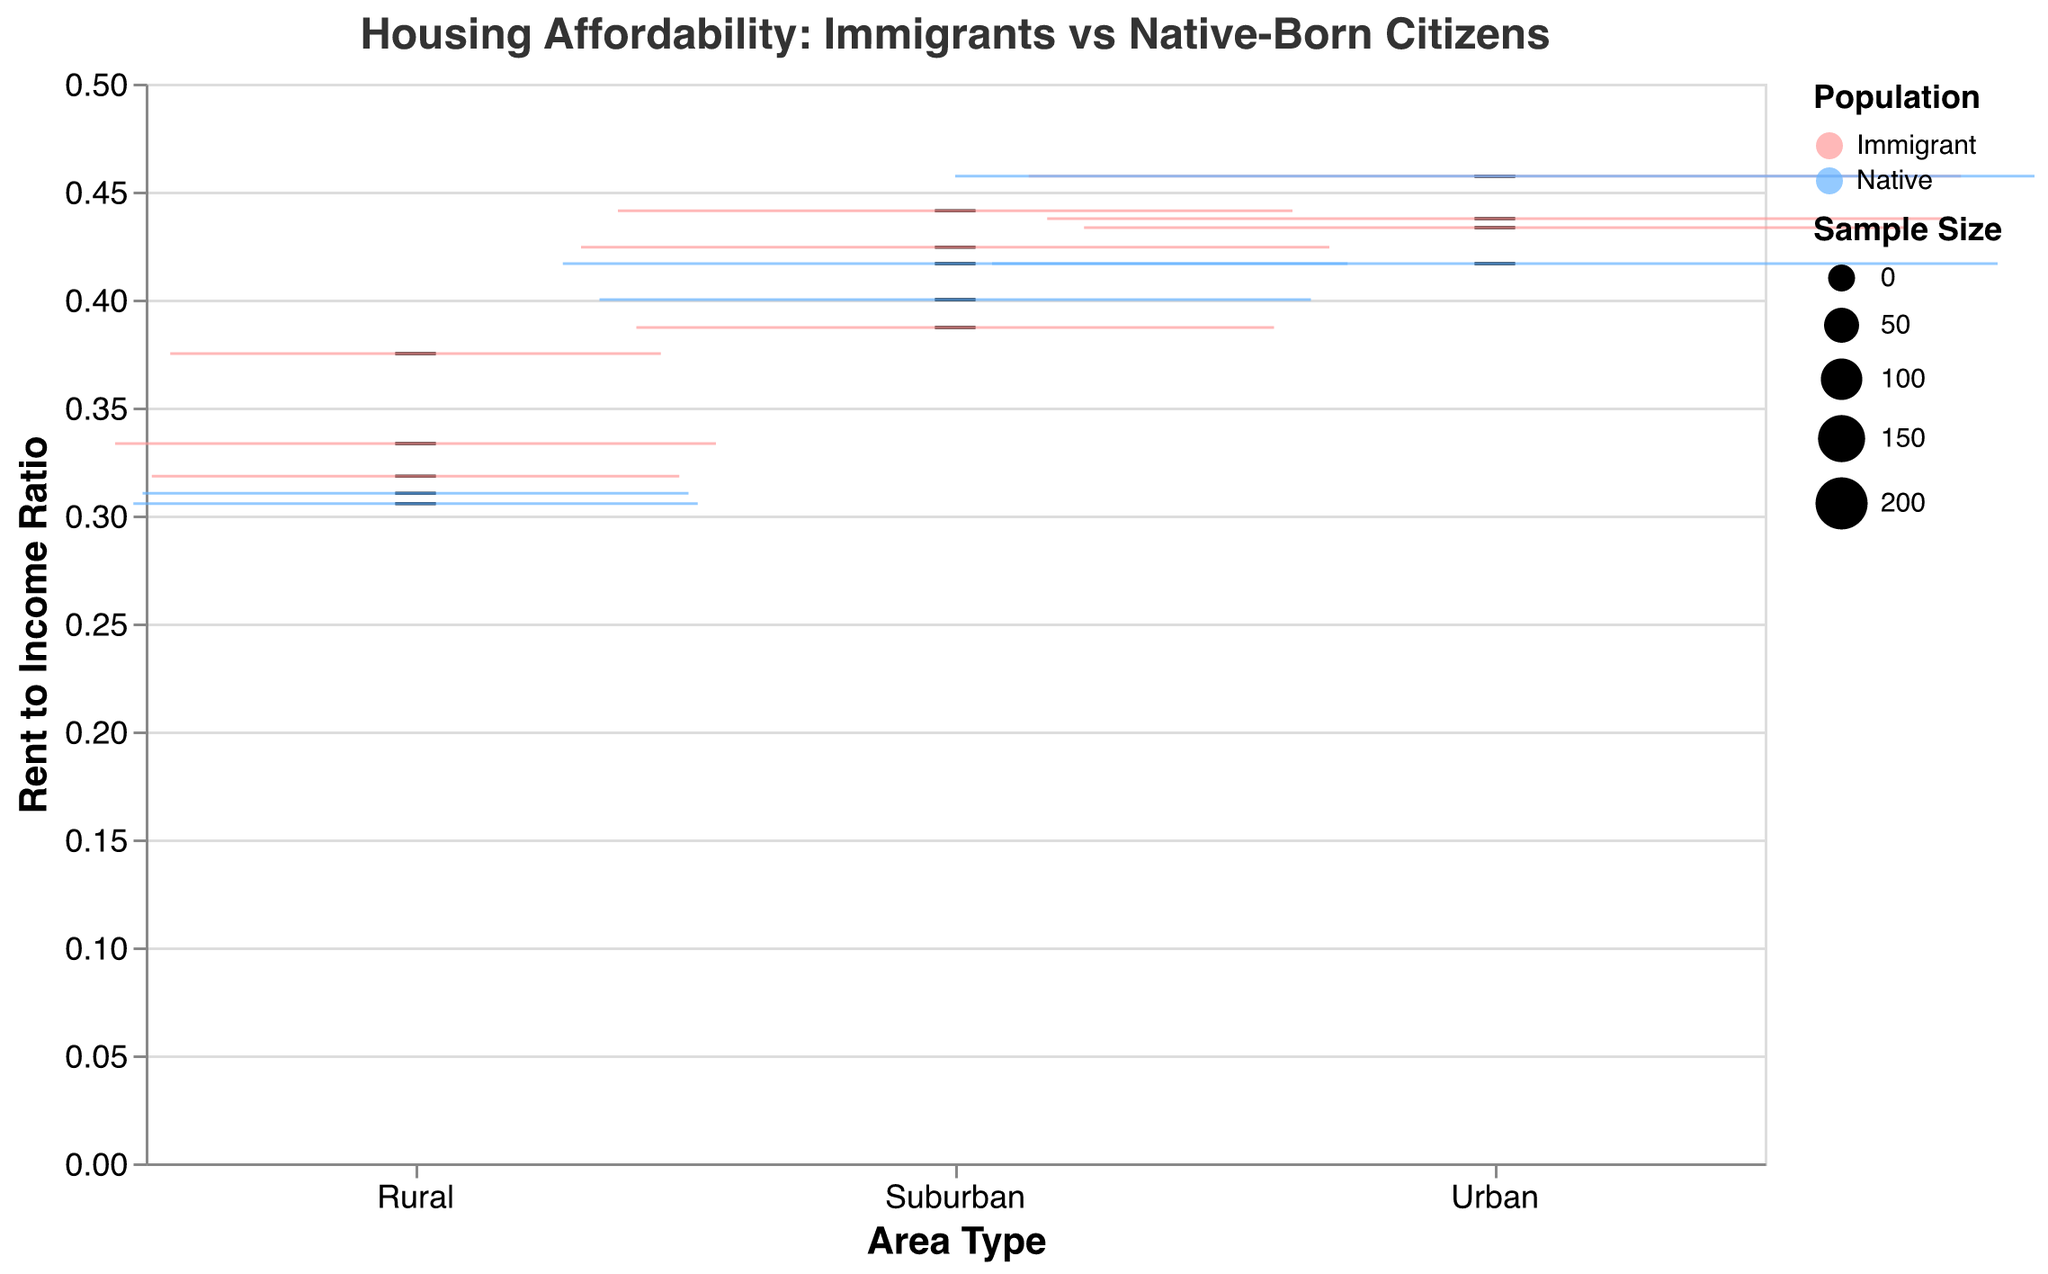What is the title of the plot? The title of the plot is displayed at the top and reads "Housing Affordability: Immigrants vs Native-Born Citizens."
Answer: Housing Affordability: Immigrants vs Native-Born Citizens Which areas are compared in the plot? The x-axis label shows the areas being compared are Urban, Suburban, and Rural.
Answer: Urban, Suburban, and Rural Which population group has a lower rent-to-income ratio in urban areas? By observing the color of the box plots in the "Urban" section, blue represents Native and pink represents Immigrant. The pink box plot is generally lower than the blue one, indicating immigrants have a slightly lower rent-to-income ratio in urban areas.
Answer: Immigrant Which type of area shows the smallest variability in rent-to-income ratios for immigrants? To determine variability, look at the spread of the box plot whiskers for the pink (Immigrant) box plots. In rural areas, the whisker spread is smaller compared to suburban and urban areas.
Answer: Rural What is the rent-to-income ratio range for native-born citizens in suburban areas? For suburban areas, the blue box plot (Native) starts at approximately 0.30 and ends at around 0.45.
Answer: 0.30 to 0.45 In which area is the rent-to-income ratio for natives higher than for immigrants? By comparing the box plots for each area: In urban, suburban, and rural areas, the blue box plots (Native) are higher than the pink ones (Immigrant). But the difference is most pronounced in the suburban area.
Answer: Suburban For which group and area is the median rent-to-income ratio the highest? Identify the highest median lines (white) among all box plots. The highest white line appears in the suburban area for Native-Born citizens.
Answer: Native, Suburban What is the sample size range used in this plot? Sample sizes are indicated by the size of the boxes. The range can be inferred from the legend where it mentions the smallest size is 60 and the largest size is 220.
Answer: 60 to 220 How does housing affordability for immigrants in urban areas compare to rural areas? Compare the box plots for pink (Immigrant) in urban and rural sections. The rent-to-income ratio in rural areas is much lower, indicating greater affordability.
Answer: More affordable in rural areas Which region within the suburban group shows the lowest average rent for immigrants? For immigrants in suburban areas, we look at the individual data points under "Suburban". Essex County has the lowest average rent of $1200.
Answer: Essex County 